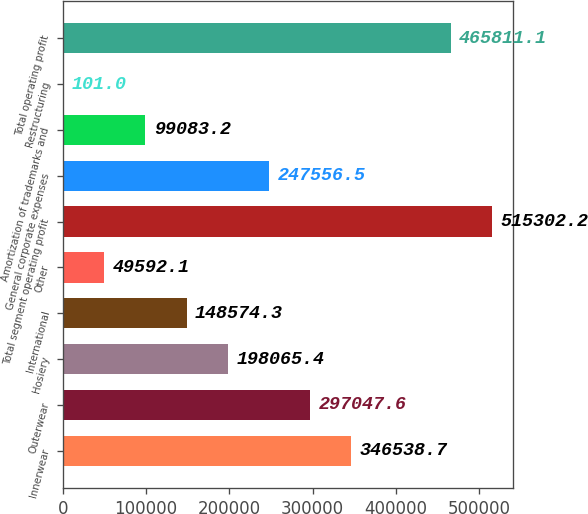Convert chart to OTSL. <chart><loc_0><loc_0><loc_500><loc_500><bar_chart><fcel>Innerwear<fcel>Outerwear<fcel>Hosiery<fcel>International<fcel>Other<fcel>Total segment operating profit<fcel>General corporate expenses<fcel>Amortization of trademarks and<fcel>Restructuring<fcel>Total operating profit<nl><fcel>346539<fcel>297048<fcel>198065<fcel>148574<fcel>49592.1<fcel>515302<fcel>247556<fcel>99083.2<fcel>101<fcel>465811<nl></chart> 